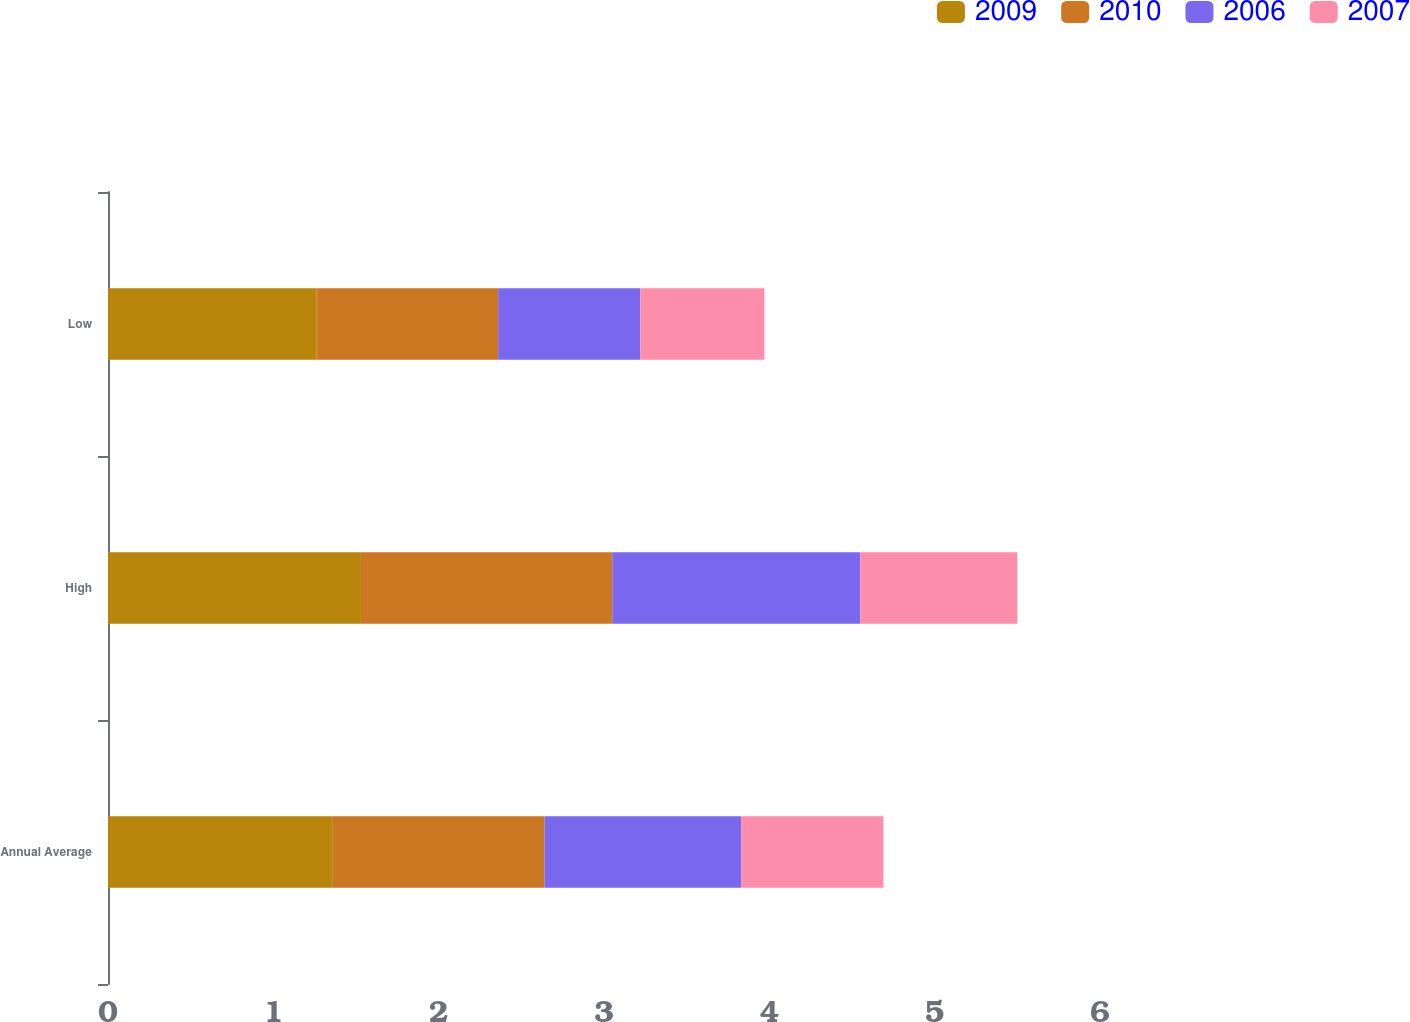<chart> <loc_0><loc_0><loc_500><loc_500><stacked_bar_chart><ecel><fcel>Annual Average<fcel>High<fcel>Low<nl><fcel>2009<fcel>1.36<fcel>1.53<fcel>1.26<nl><fcel>2010<fcel>1.28<fcel>1.52<fcel>1.1<nl><fcel>2006<fcel>1.19<fcel>1.5<fcel>0.86<nl><fcel>2007<fcel>0.86<fcel>0.95<fcel>0.75<nl></chart> 